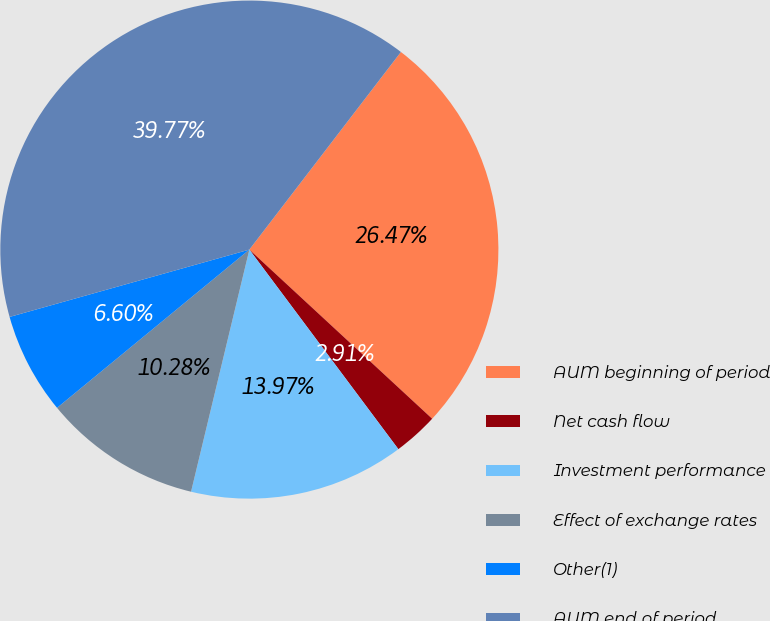Convert chart to OTSL. <chart><loc_0><loc_0><loc_500><loc_500><pie_chart><fcel>AUM beginning of period<fcel>Net cash flow<fcel>Investment performance<fcel>Effect of exchange rates<fcel>Other(1)<fcel>AUM end of period<nl><fcel>26.47%<fcel>2.91%<fcel>13.97%<fcel>10.28%<fcel>6.6%<fcel>39.77%<nl></chart> 